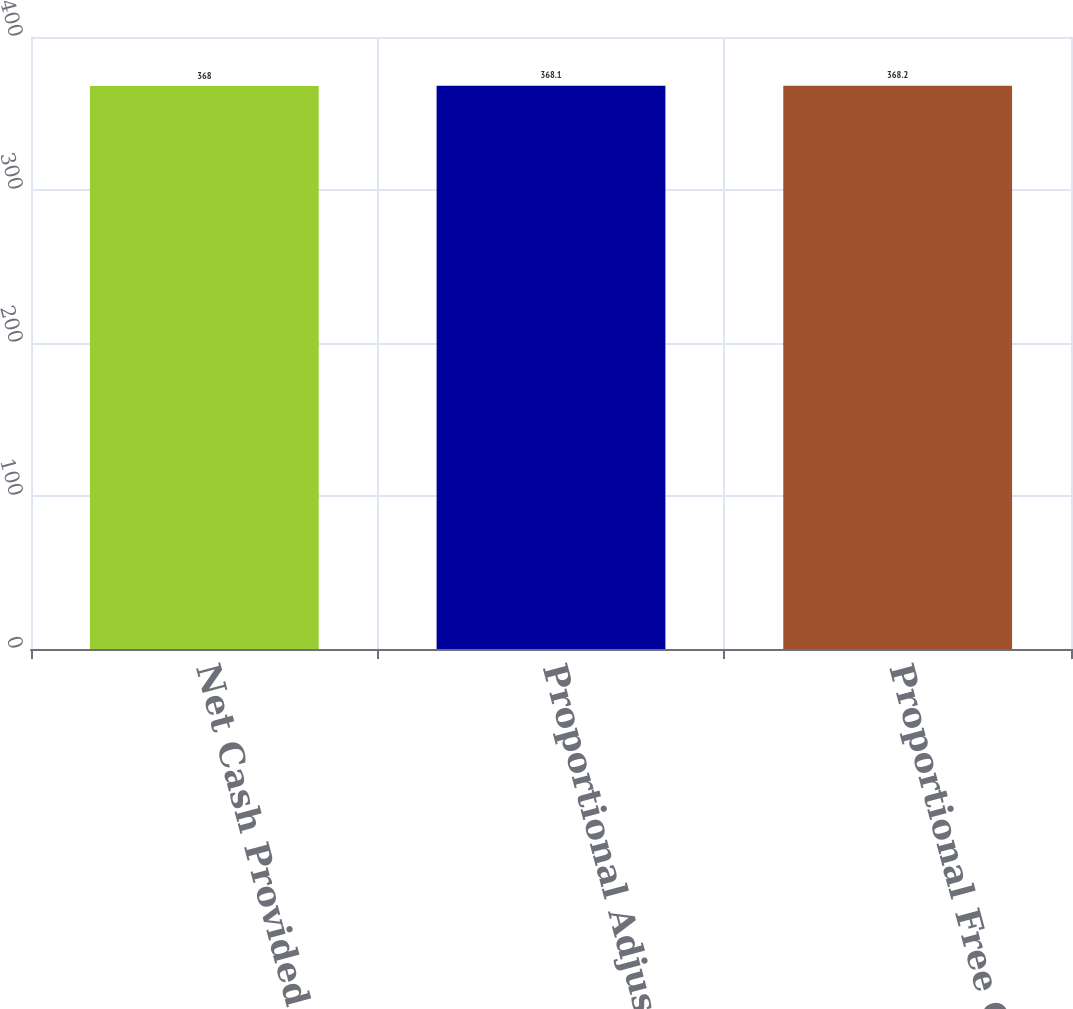Convert chart to OTSL. <chart><loc_0><loc_0><loc_500><loc_500><bar_chart><fcel>Net Cash Provided by Operating<fcel>Proportional Adjusted<fcel>Proportional Free Cash Flow<nl><fcel>368<fcel>368.1<fcel>368.2<nl></chart> 